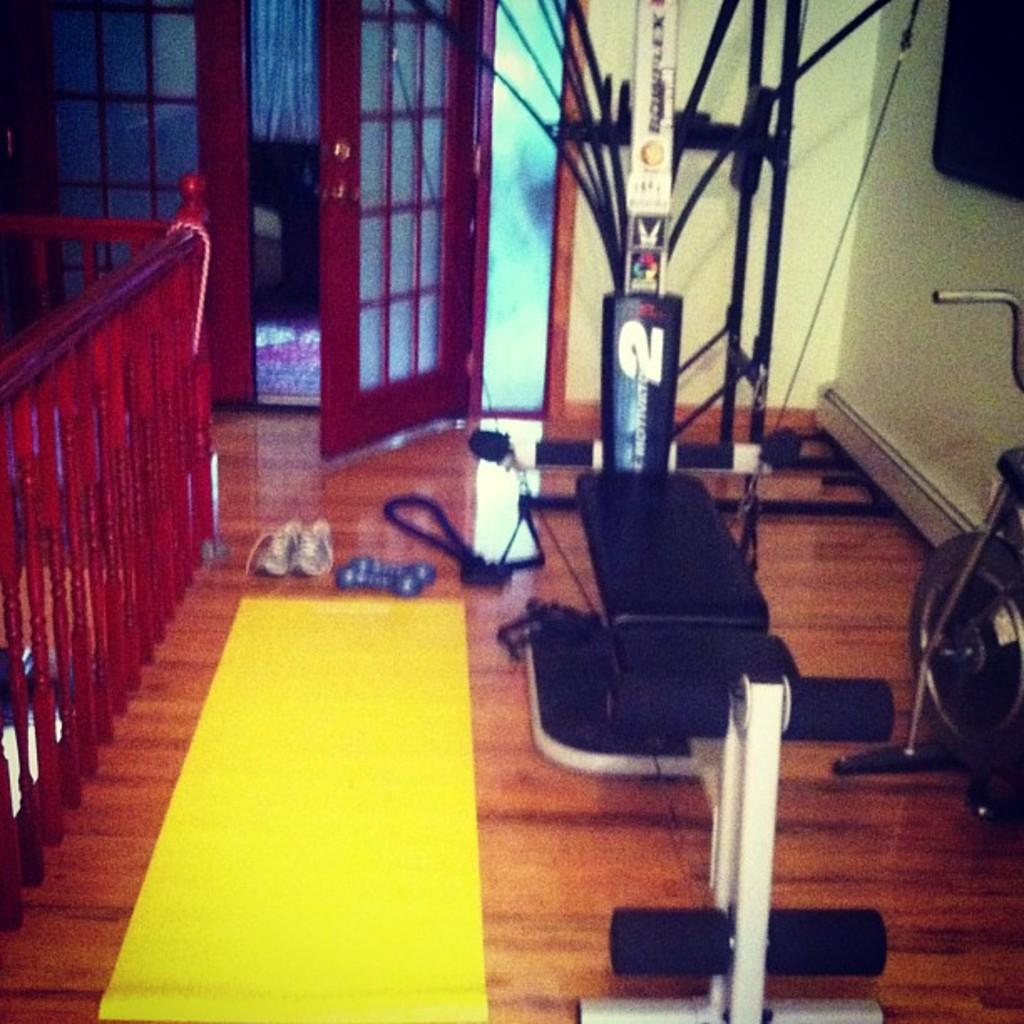What type of floor covering is visible in the image? There is a mat in the image. What type of seating is present in the image? There is a bench in the image. What type of exercise equipment can be seen in the image? There are weights in the image. What is the medical term for the rhythmic contraction and relaxation of the heart muscle? There is a cardiac cycle in the image. What type of footwear is visible on the floor in the image? There are shoes on the floor in the image. What type of entryway is present in the image? There is a door in the image. What type of barrier is present on the side in the image? There is a wooden fence on the side in the image. What type of trousers is the kettle wearing in the image? There is no kettle present in the image, and therefore no trousers or kettle can be observed. What design is featured on the weights in the image? The weights in the image do not have a specific design; they are plain and functional. 